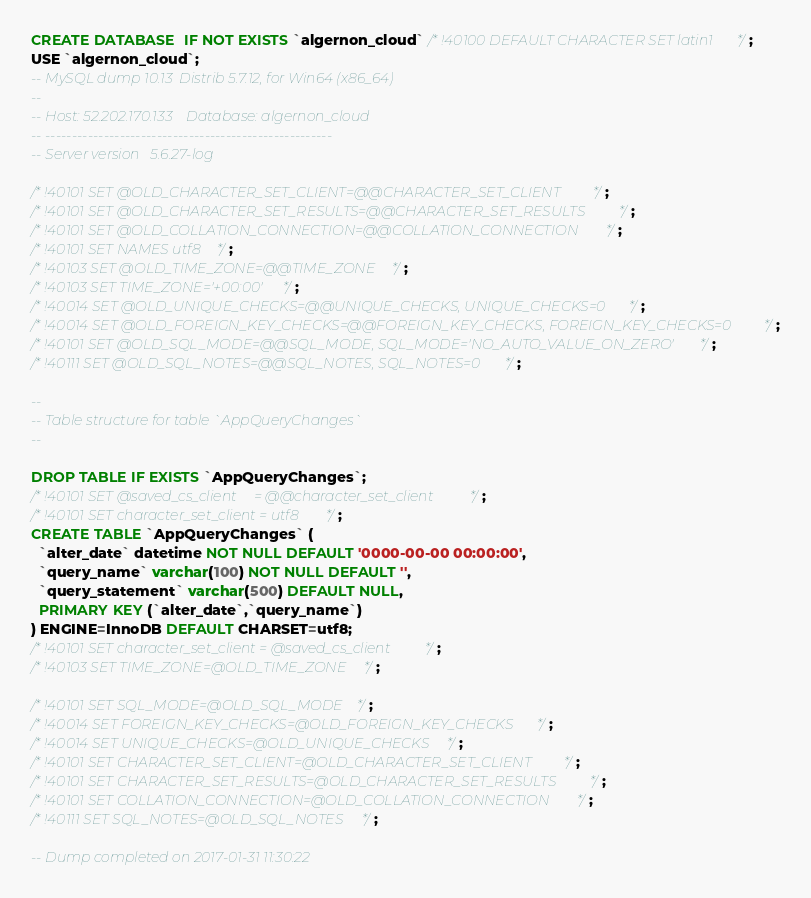<code> <loc_0><loc_0><loc_500><loc_500><_SQL_>CREATE DATABASE  IF NOT EXISTS `algernon_cloud` /*!40100 DEFAULT CHARACTER SET latin1 */;
USE `algernon_cloud`;
-- MySQL dump 10.13  Distrib 5.7.12, for Win64 (x86_64)
--
-- Host: 52.202.170.133    Database: algernon_cloud
-- ------------------------------------------------------
-- Server version	5.6.27-log

/*!40101 SET @OLD_CHARACTER_SET_CLIENT=@@CHARACTER_SET_CLIENT */;
/*!40101 SET @OLD_CHARACTER_SET_RESULTS=@@CHARACTER_SET_RESULTS */;
/*!40101 SET @OLD_COLLATION_CONNECTION=@@COLLATION_CONNECTION */;
/*!40101 SET NAMES utf8 */;
/*!40103 SET @OLD_TIME_ZONE=@@TIME_ZONE */;
/*!40103 SET TIME_ZONE='+00:00' */;
/*!40014 SET @OLD_UNIQUE_CHECKS=@@UNIQUE_CHECKS, UNIQUE_CHECKS=0 */;
/*!40014 SET @OLD_FOREIGN_KEY_CHECKS=@@FOREIGN_KEY_CHECKS, FOREIGN_KEY_CHECKS=0 */;
/*!40101 SET @OLD_SQL_MODE=@@SQL_MODE, SQL_MODE='NO_AUTO_VALUE_ON_ZERO' */;
/*!40111 SET @OLD_SQL_NOTES=@@SQL_NOTES, SQL_NOTES=0 */;

--
-- Table structure for table `AppQueryChanges`
--

DROP TABLE IF EXISTS `AppQueryChanges`;
/*!40101 SET @saved_cs_client     = @@character_set_client */;
/*!40101 SET character_set_client = utf8 */;
CREATE TABLE `AppQueryChanges` (
  `alter_date` datetime NOT NULL DEFAULT '0000-00-00 00:00:00',
  `query_name` varchar(100) NOT NULL DEFAULT '',
  `query_statement` varchar(500) DEFAULT NULL,
  PRIMARY KEY (`alter_date`,`query_name`)
) ENGINE=InnoDB DEFAULT CHARSET=utf8;
/*!40101 SET character_set_client = @saved_cs_client */;
/*!40103 SET TIME_ZONE=@OLD_TIME_ZONE */;

/*!40101 SET SQL_MODE=@OLD_SQL_MODE */;
/*!40014 SET FOREIGN_KEY_CHECKS=@OLD_FOREIGN_KEY_CHECKS */;
/*!40014 SET UNIQUE_CHECKS=@OLD_UNIQUE_CHECKS */;
/*!40101 SET CHARACTER_SET_CLIENT=@OLD_CHARACTER_SET_CLIENT */;
/*!40101 SET CHARACTER_SET_RESULTS=@OLD_CHARACTER_SET_RESULTS */;
/*!40101 SET COLLATION_CONNECTION=@OLD_COLLATION_CONNECTION */;
/*!40111 SET SQL_NOTES=@OLD_SQL_NOTES */;

-- Dump completed on 2017-01-31 11:30:22
</code> 